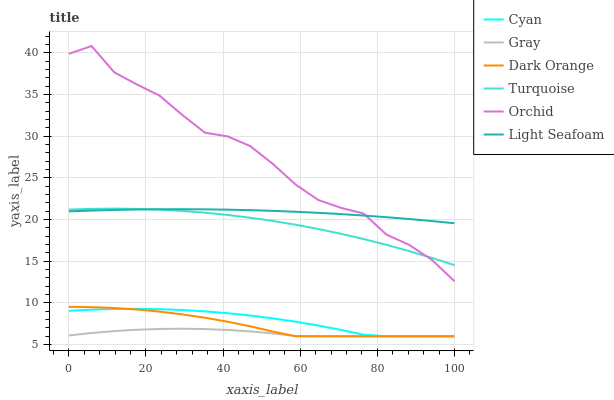Does Gray have the minimum area under the curve?
Answer yes or no. Yes. Does Orchid have the maximum area under the curve?
Answer yes or no. Yes. Does Turquoise have the minimum area under the curve?
Answer yes or no. No. Does Turquoise have the maximum area under the curve?
Answer yes or no. No. Is Light Seafoam the smoothest?
Answer yes or no. Yes. Is Orchid the roughest?
Answer yes or no. Yes. Is Turquoise the smoothest?
Answer yes or no. No. Is Turquoise the roughest?
Answer yes or no. No. Does Dark Orange have the lowest value?
Answer yes or no. Yes. Does Turquoise have the lowest value?
Answer yes or no. No. Does Orchid have the highest value?
Answer yes or no. Yes. Does Turquoise have the highest value?
Answer yes or no. No. Is Dark Orange less than Turquoise?
Answer yes or no. Yes. Is Turquoise greater than Cyan?
Answer yes or no. Yes. Does Turquoise intersect Light Seafoam?
Answer yes or no. Yes. Is Turquoise less than Light Seafoam?
Answer yes or no. No. Is Turquoise greater than Light Seafoam?
Answer yes or no. No. Does Dark Orange intersect Turquoise?
Answer yes or no. No. 